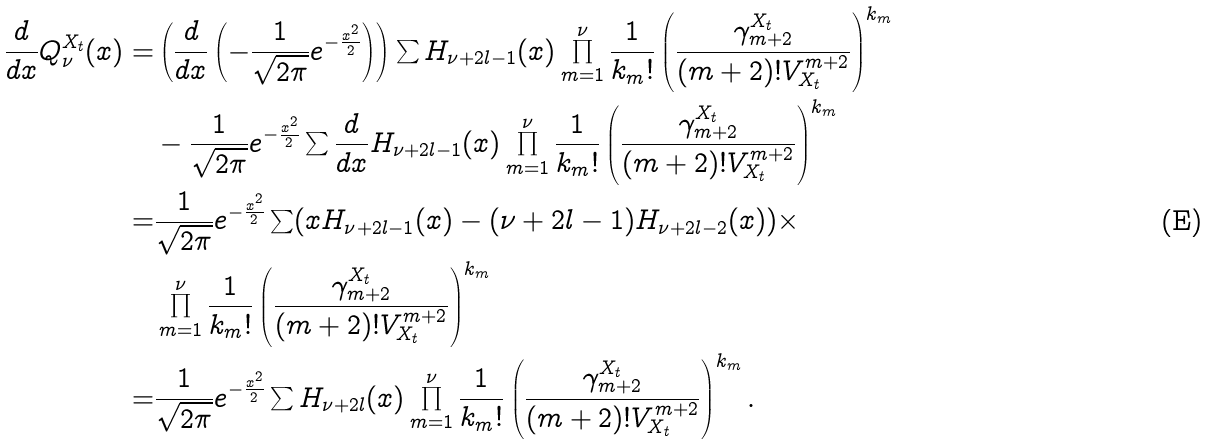<formula> <loc_0><loc_0><loc_500><loc_500>\frac { d } { d x } Q _ { \nu } ^ { X _ { t } } ( x ) = & \left ( \frac { d } { d x } \left ( - \frac { 1 } { \sqrt { 2 \pi } } e ^ { - \frac { x ^ { 2 } } { 2 } } \right ) \right ) \sum H _ { \nu + 2 l - 1 } ( x ) \prod _ { m = 1 } ^ { \nu } \frac { 1 } { k _ { m } ! } \left ( \frac { \gamma ^ { X _ { t } } _ { m + 2 } } { ( m + 2 ) ! V _ { X _ { t } } ^ { m + 2 } } \right ) ^ { k _ { m } } \\ & - \frac { 1 } { \sqrt { 2 \pi } } e ^ { - \frac { x ^ { 2 } } { 2 } } \sum \frac { d } { d x } H _ { \nu + 2 l - 1 } ( x ) \prod _ { m = 1 } ^ { \nu } \frac { 1 } { k _ { m } ! } \left ( \frac { \gamma ^ { X _ { t } } _ { m + 2 } } { ( m + 2 ) ! V _ { X _ { t } } ^ { m + 2 } } \right ) ^ { k _ { m } } \\ = & \frac { 1 } { \sqrt { 2 \pi } } e ^ { - \frac { x ^ { 2 } } { 2 } } \sum ( x H _ { \nu + 2 l - 1 } ( x ) - ( \nu + 2 l - 1 ) H _ { \nu + 2 l - 2 } ( x ) ) \times \\ & \prod _ { m = 1 } ^ { \nu } \frac { 1 } { k _ { m } ! } \left ( \frac { \gamma ^ { X _ { t } } _ { m + 2 } } { ( m + 2 ) ! V _ { X _ { t } } ^ { m + 2 } } \right ) ^ { k _ { m } } \\ = & \frac { 1 } { \sqrt { 2 \pi } } e ^ { - \frac { x ^ { 2 } } { 2 } } \sum H _ { \nu + 2 l } ( x ) \prod _ { m = 1 } ^ { \nu } \frac { 1 } { k _ { m } ! } \left ( \frac { \gamma ^ { X _ { t } } _ { m + 2 } } { ( m + 2 ) ! V _ { X _ { t } } ^ { m + 2 } } \right ) ^ { k _ { m } } .</formula> 